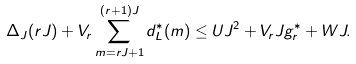Convert formula to latex. <formula><loc_0><loc_0><loc_500><loc_500>\Delta _ { J } ( r J ) + V _ { r } \sum _ { m = r J + 1 } ^ { ( r + 1 ) J } d _ { L } ^ { * } ( m ) \leq U J ^ { 2 } + V _ { r } J g ^ { * } _ { r } + W J .</formula> 